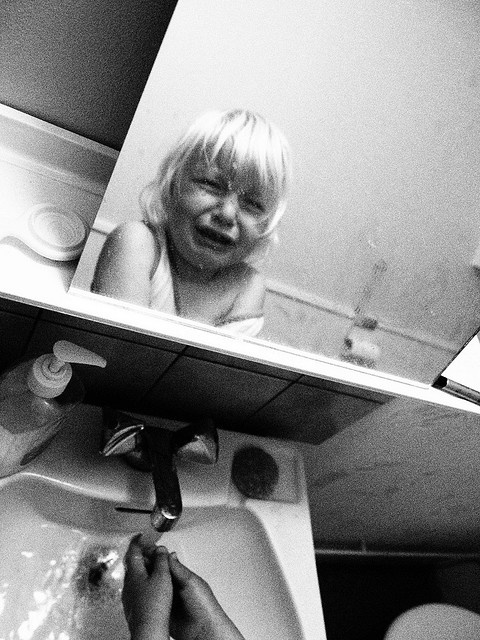Describe the objects in this image and their specific colors. I can see sink in gray, darkgray, lightgray, and black tones, people in gray, lightgray, darkgray, and black tones, people in gray, black, darkgray, and lightgray tones, bottle in gray, black, darkgray, and lightgray tones, and toilet in gray, darkgray, black, and lightgray tones in this image. 